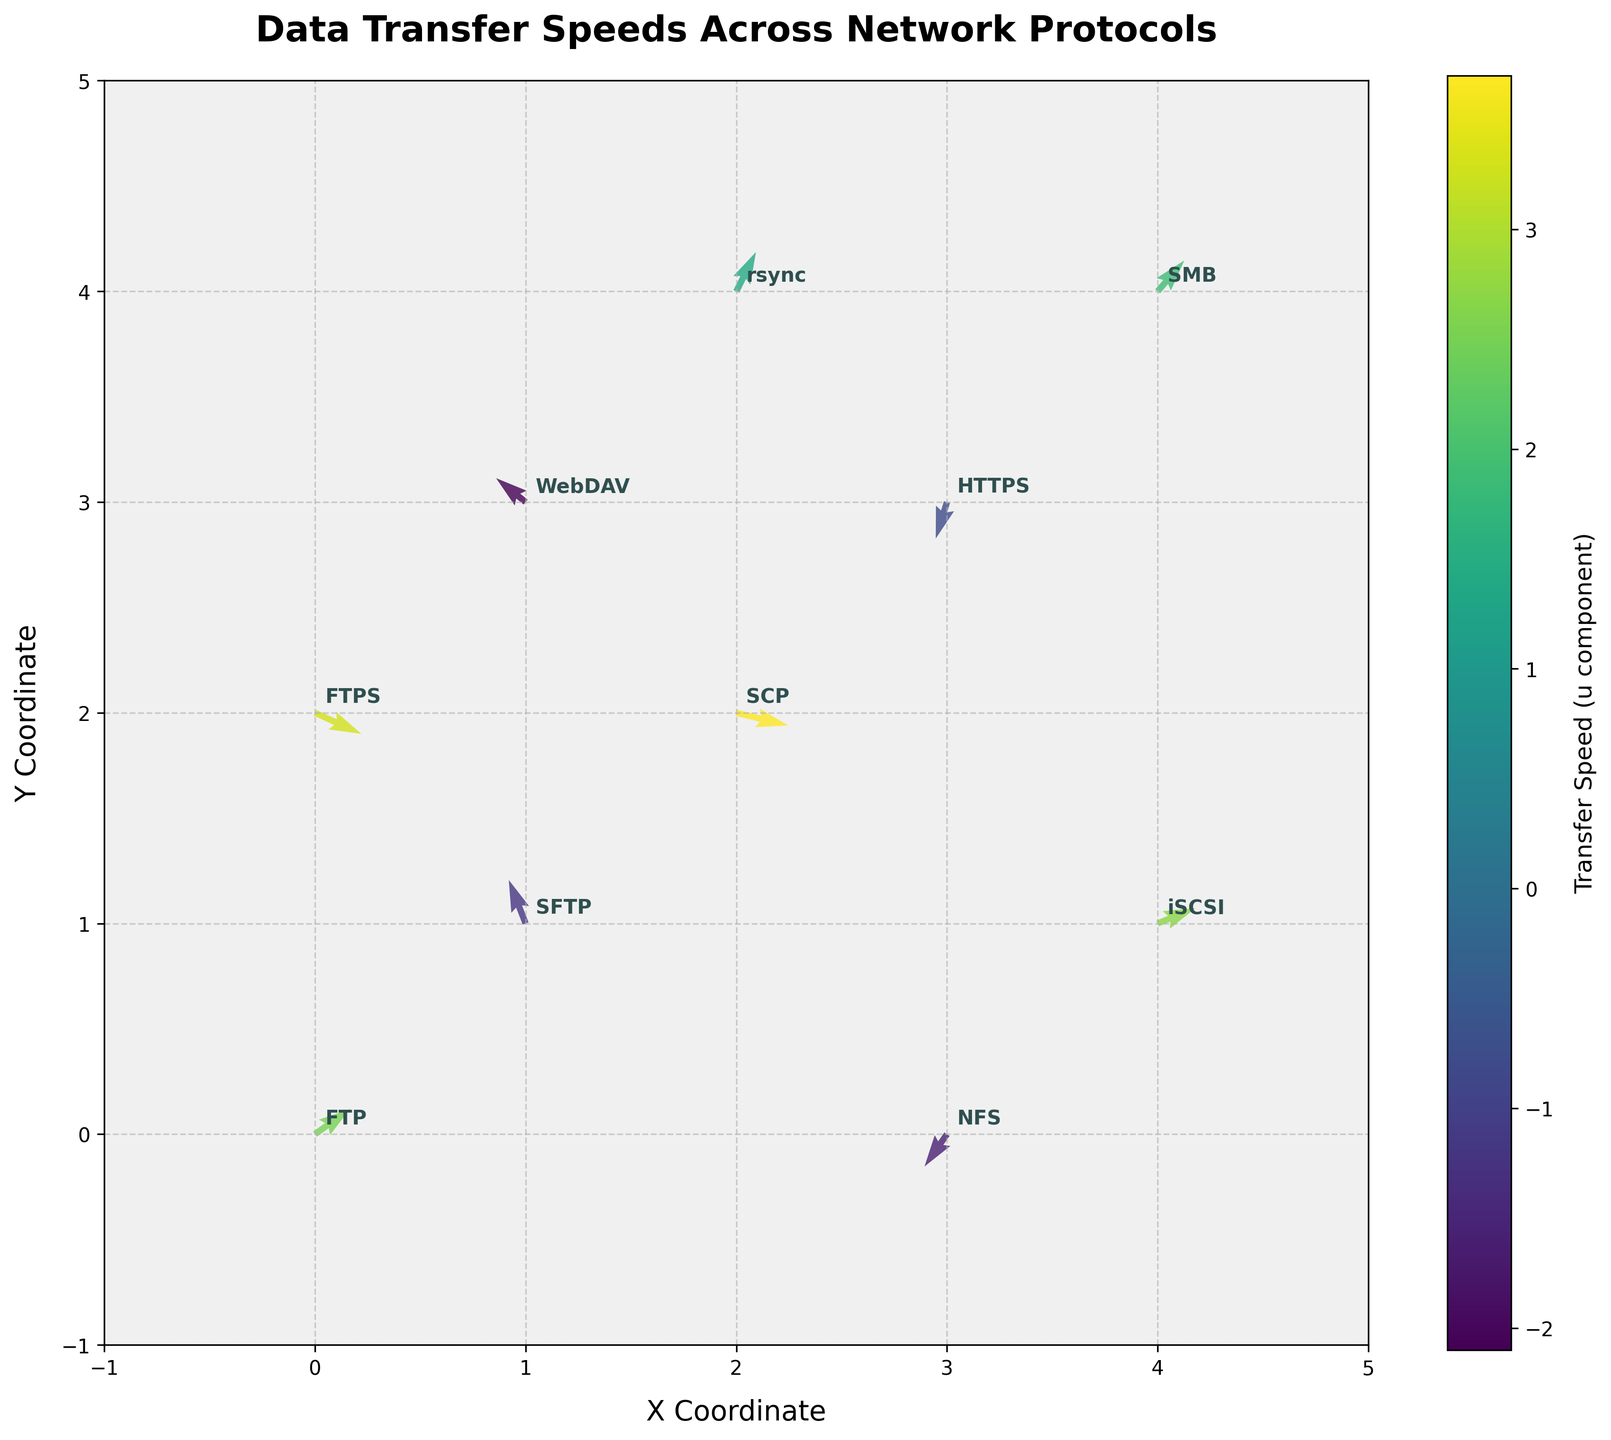what is the title of the figure? The title of the figure is located at the top of the plot and usually gives an overview of what the figure represents. In this case, the title is 'Data Transfer Speeds Across Network Protocols'.
Answer: Data Transfer Speeds Across Network Protocols How many unique data points are displayed in the figure? There is a distinct number of quivers in the plot, each representing a unique data point. By looking at the annotations, we can count the number of unique protocols.
Answer: 10 Which protocol has the highest transfer speed in the u component? To find the protocol with the highest transfer speed in the u component, we need to look at the quivers' magnitudes and their corresponding annotations. The length of the quiver represents the u component. Protocol 'SCP' has the highest positive u value of 3.7.
Answer: SCP What is the direction of data transfer for the 'NFS' protocol? The direction of data transfer is shown by the quiver's orientation. For 'NFS,' the arrow points from (3,0) towards the direction of (-1.6,-2.3). Therefore, the direction is towards negative x and y.
Answer: Negative X and Y Which protocol shows a negative transfer speed in both the u and v components? To determine which protocol shows negative values in both components, we need to examine the quivers with annotations. The protocol 'HTTPS' has values (-0.8, -2.6), indicating negative transfer speeds in both u and v components.
Answer: HTTPS Compare the transfer speed magnitudes of 'FTP' and 'FTPS' and indicate which is greater. The magnitude of a vector is calculated as √(u^2 + v^2). For 'FTP': √(2.5^2 + 1.8^2) = √(6.25 + 3.24) = √9.49 ≈ 3.08. For 'FTPS': √(3.3^2 + (-1.5)^2) = √(10.89 + 2.25) = √13.14 ≈ 3.62. Comparing these magnitudes, 'FTPS' has a greater transfer speed magnitude.
Answer: FTPS Which protocol's data transfer direction has the highest y component? The v component denotes the y direction. By examining the quivers, 'SFTP' has the highest positive y component value of 3.1.
Answer: SFTP What is the average transfer speed in the u component for 'FTP' and 'SMB'? The average is calculated by summing the u components and dividing by the number of protocols. For FTP and SMB: (2.5 + 1.9)/2 = 4.4/2 = 2.2
Answer: 2.2 Which protocol has the shortest quiver length? The shortest quiver length corresponds to the smallest magnitude of the vector given by √(u^2 + v^2). Calculating for each shows that 'HTTPS' has the shortest quiver with a magnitude of √((-0.8)^2 + (-2.6)^2) ≈ 2.74.
Answer: HTTPS 